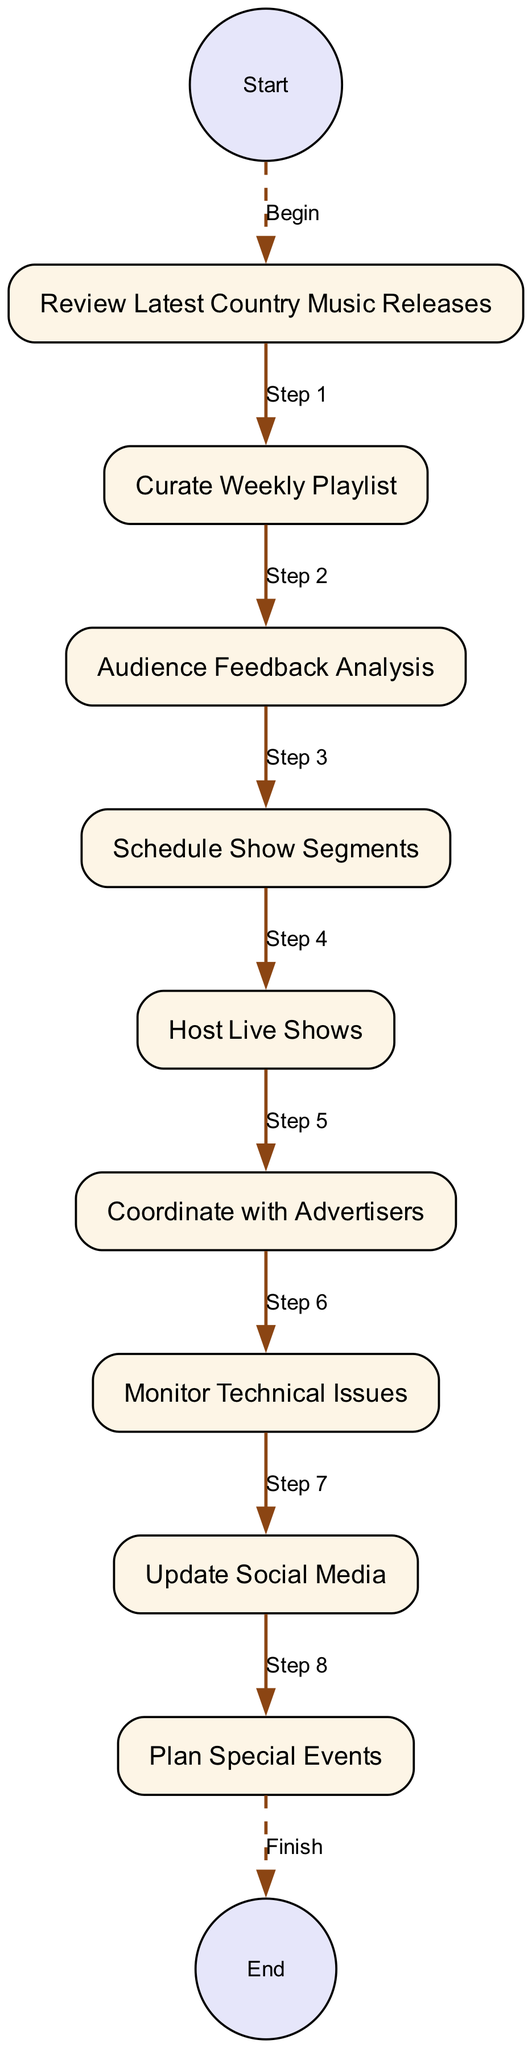What is the first activity in the diagram? The diagram starts with the first node labeled "Review Latest Country Music Releases." This is the first activity listed in the sequence of tasks.
Answer: Review Latest Country Music Releases How many activities are shown in the diagram? The diagram presents a total of eight distinct activities, as counted from the nodes representing each task in the weekly routine.
Answer: Eight What is the last activity before the end node? The last activity before reaching the end node is "Update Social Media." This is the last task completed in the flow leading to the end.
Answer: Update Social Media What activity follows "Audience Feedback Analysis"? The activity that comes after "Audience Feedback Analysis" is "Schedule Show Segments," which is the next step in the routine process.
Answer: Schedule Show Segments How are "Host Live Shows" and "Coordinate with Advertisers" connected in the diagram? "Host Live Shows" and "Coordinate with Advertisers" are connected through edges in the sequence, indicating the order of activities where the DJ must effectively engage the audience and manage advertisers closely together in their routine.
Answer: Sequential connection Which activity directly precedes "Plan Special Events"? The activity that directly precedes "Plan Special Events" is "Update Social Media." This indicates the flow of tasks leading up to event planning.
Answer: Update Social Media What color is used to represent the start and end nodes in the diagram? The start and end nodes are colored with "E6E6FA," which is a light lavender shade, differentiating them from the activity nodes.
Answer: Light lavender How many edges are drawn from the start node? There is one edge drawn from the start node, leading to the first activity, indicating that the process begins with this single step.
Answer: One What is the main focus of the activity "Curate Weekly Playlist"? The primary focus of "Curate Weekly Playlist" is to select a mix of songs for the show, combining classic hits, new releases, and audience favorites to create an engaging playlist.
Answer: Selecting songs 